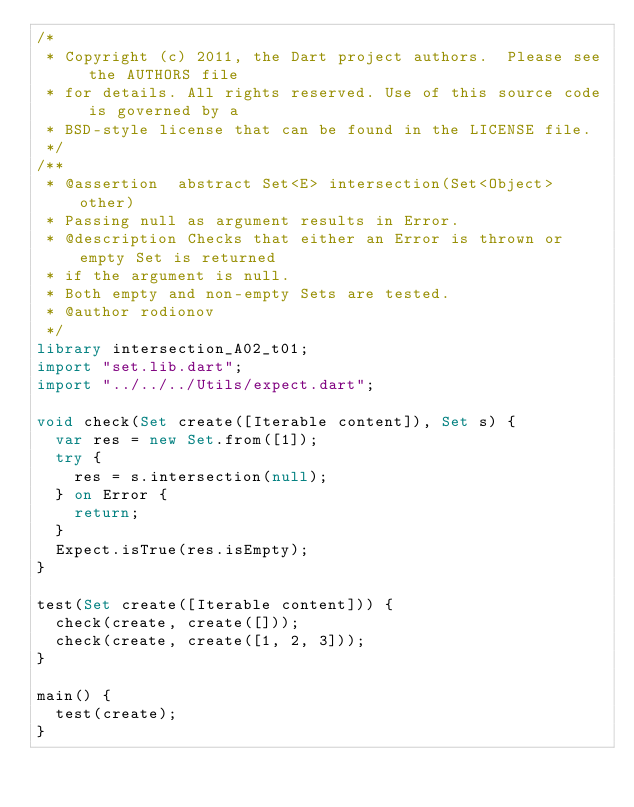<code> <loc_0><loc_0><loc_500><loc_500><_Dart_>/*
 * Copyright (c) 2011, the Dart project authors.  Please see the AUTHORS file
 * for details. All rights reserved. Use of this source code is governed by a
 * BSD-style license that can be found in the LICENSE file.
 */
/**
 * @assertion  abstract Set<E> intersection(Set<Object> other)
 * Passing null as argument results in Error. 
 * @description Checks that either an Error is thrown or empty Set is returned
 * if the argument is null.
 * Both empty and non-empty Sets are tested.
 * @author rodionov
 */
library intersection_A02_t01;
import "set.lib.dart";
import "../../../Utils/expect.dart";

void check(Set create([Iterable content]), Set s) {
  var res = new Set.from([1]);
  try {
    res = s.intersection(null);
  } on Error {
    return;
  }
  Expect.isTrue(res.isEmpty);
}

test(Set create([Iterable content])) {
  check(create, create([]));
  check(create, create([1, 2, 3]));
}

main() {
  test(create);
}
</code> 